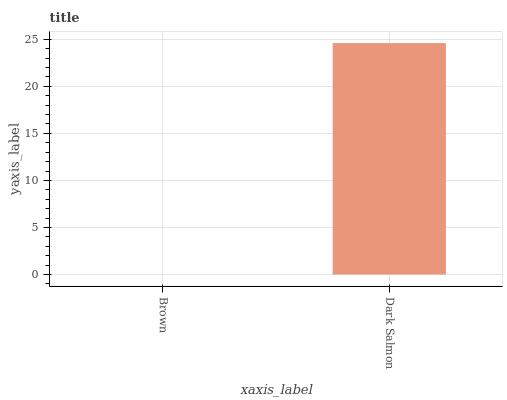Is Brown the minimum?
Answer yes or no. Yes. Is Dark Salmon the maximum?
Answer yes or no. Yes. Is Dark Salmon the minimum?
Answer yes or no. No. Is Dark Salmon greater than Brown?
Answer yes or no. Yes. Is Brown less than Dark Salmon?
Answer yes or no. Yes. Is Brown greater than Dark Salmon?
Answer yes or no. No. Is Dark Salmon less than Brown?
Answer yes or no. No. Is Dark Salmon the high median?
Answer yes or no. Yes. Is Brown the low median?
Answer yes or no. Yes. Is Brown the high median?
Answer yes or no. No. Is Dark Salmon the low median?
Answer yes or no. No. 